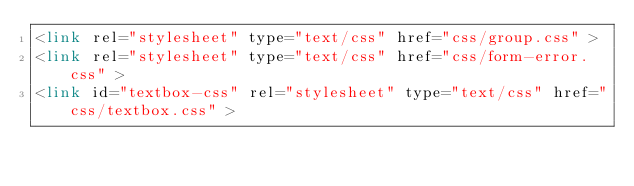Convert code to text. <code><loc_0><loc_0><loc_500><loc_500><_PHP_><link rel="stylesheet" type="text/css" href="css/group.css" >
<link rel="stylesheet" type="text/css" href="css/form-error.css" >
<link id="textbox-css" rel="stylesheet" type="text/css" href="css/textbox.css" ></code> 